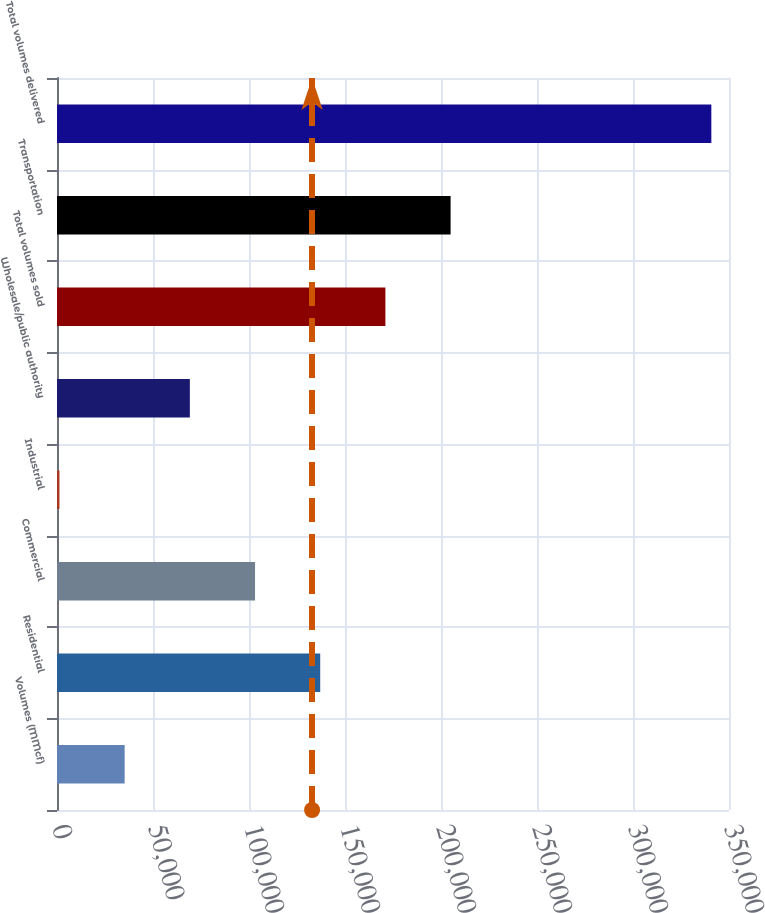Convert chart. <chart><loc_0><loc_0><loc_500><loc_500><bar_chart><fcel>Volumes (MMcf)<fcel>Residential<fcel>Commercial<fcel>Industrial<fcel>Wholesale/public authority<fcel>Total volumes sold<fcel>Transportation<fcel>Total volumes delivered<nl><fcel>35239.3<fcel>137093<fcel>103142<fcel>1288<fcel>69190.6<fcel>171044<fcel>204996<fcel>340801<nl></chart> 